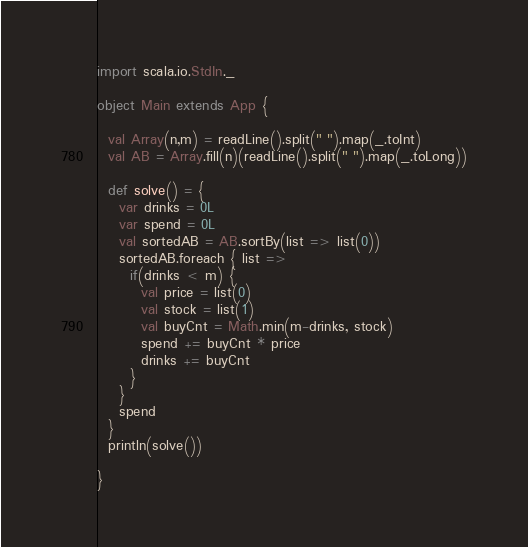Convert code to text. <code><loc_0><loc_0><loc_500><loc_500><_Scala_>import scala.io.StdIn._

object Main extends App {

  val Array(n,m) = readLine().split(" ").map(_.toInt)
  val AB = Array.fill(n)(readLine().split(" ").map(_.toLong))

  def solve() = {
    var drinks = 0L
    var spend = 0L
    val sortedAB = AB.sortBy(list => list(0))
    sortedAB.foreach { list =>
      if(drinks < m) {
        val price = list(0)
        val stock = list(1)
        val buyCnt = Math.min(m-drinks, stock)
        spend += buyCnt * price
        drinks += buyCnt
      }
    }
    spend
  }
  println(solve())

}

</code> 